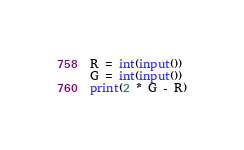Convert code to text. <code><loc_0><loc_0><loc_500><loc_500><_Python_>R = int(input())
G = int(input())
print(2 * G - R)</code> 